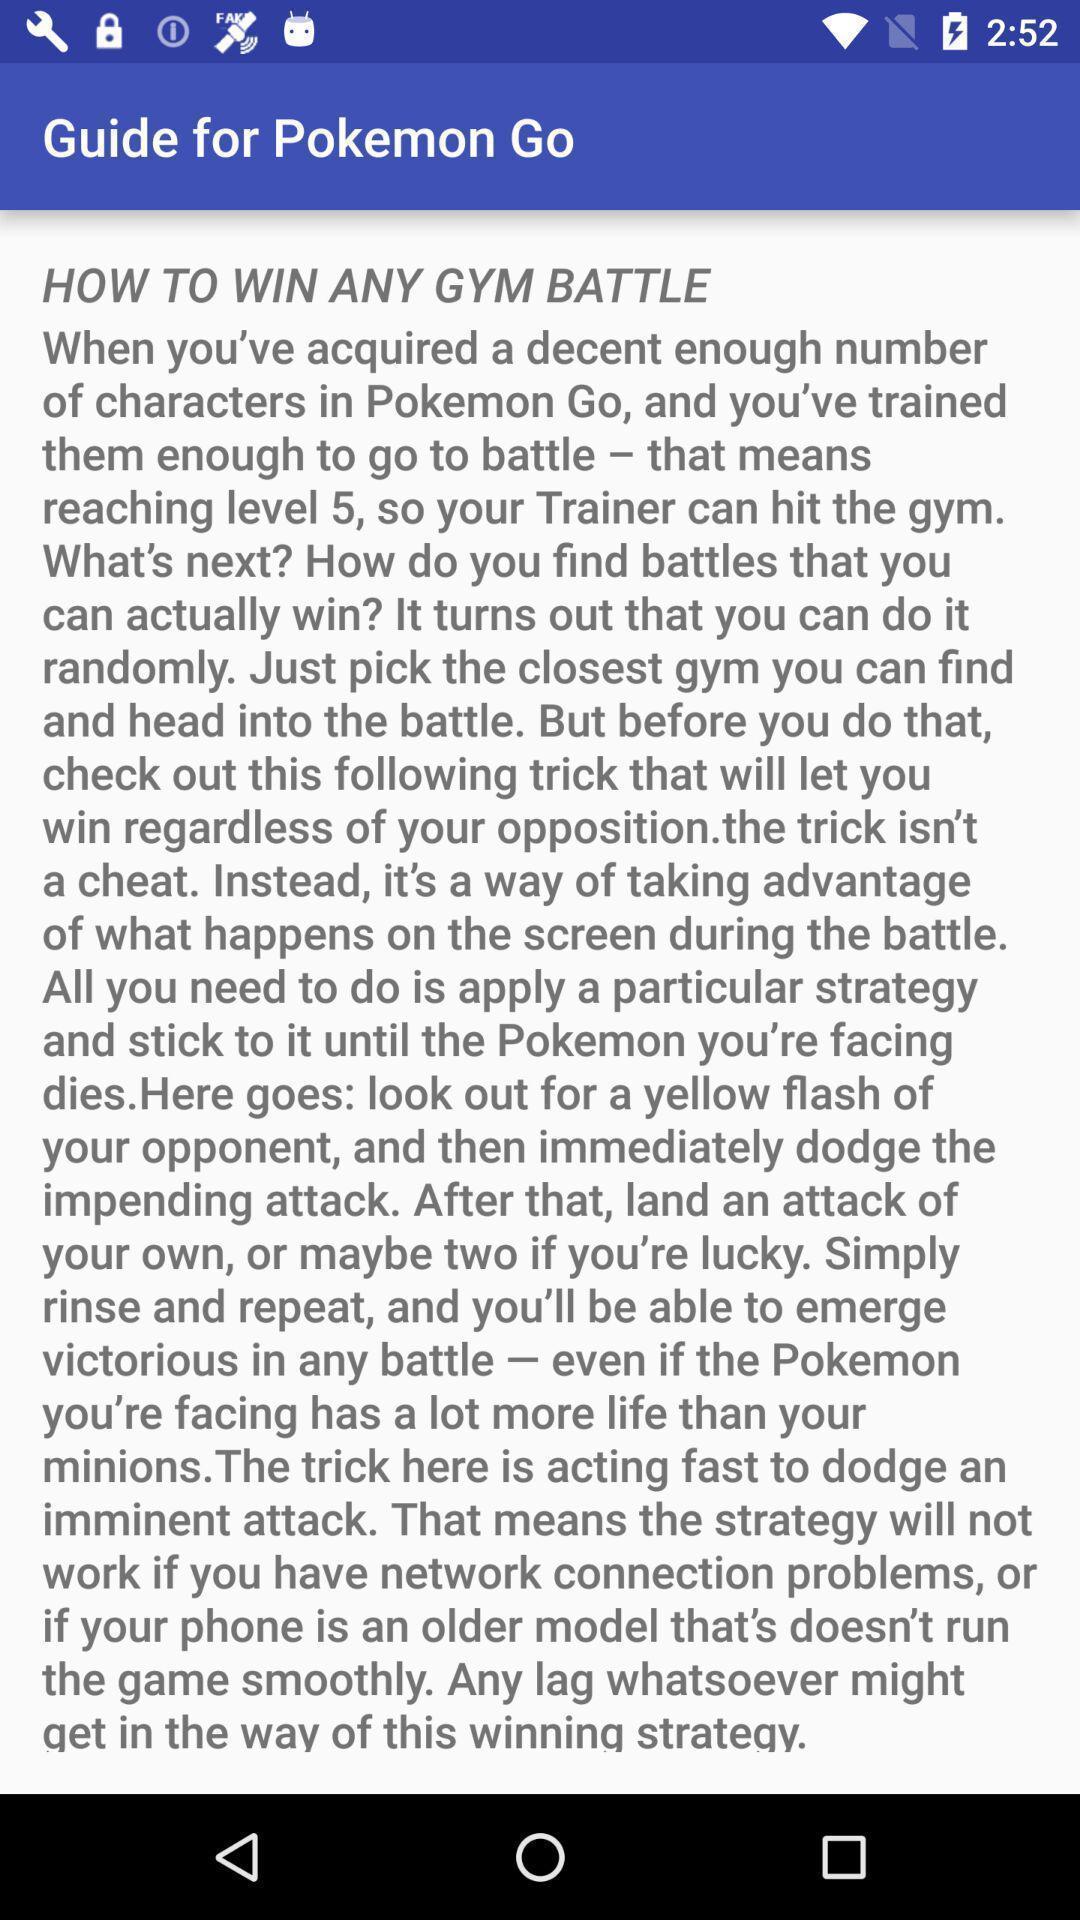Summarize the main components in this picture. Screen shows a guide to win any gym battle. 